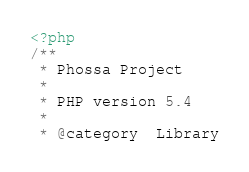<code> <loc_0><loc_0><loc_500><loc_500><_PHP_><?php
/**
 * Phossa Project
 *
 * PHP version 5.4
 *
 * @category  Library</code> 